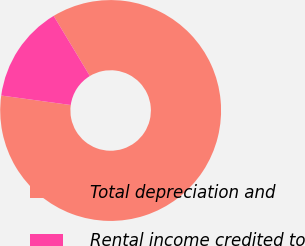<chart> <loc_0><loc_0><loc_500><loc_500><pie_chart><fcel>Total depreciation and<fcel>Rental income credited to<nl><fcel>85.79%<fcel>14.21%<nl></chart> 